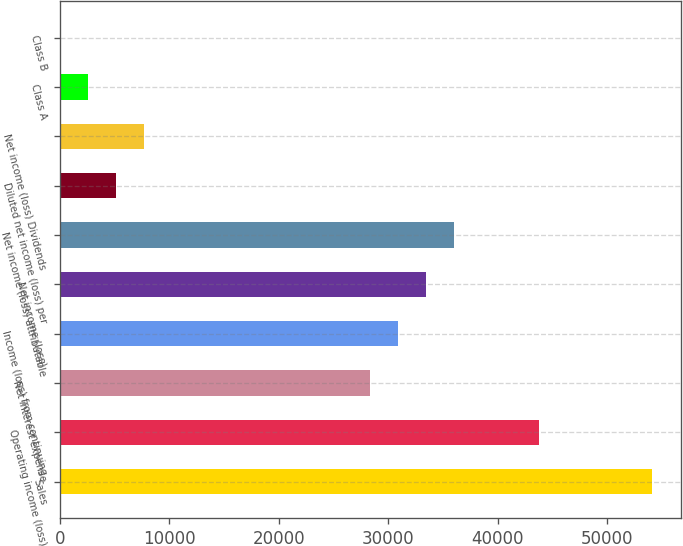Convert chart to OTSL. <chart><loc_0><loc_0><loc_500><loc_500><bar_chart><fcel>Sales<fcel>Operating income (loss)<fcel>Net interest expense<fcel>Income (loss) from continuing<fcel>Net income (loss)<fcel>Net income (loss) attributable<fcel>Diluted net income (loss) per<fcel>Net income (loss) Dividends<fcel>Class A<fcel>Class B<nl><fcel>54030.8<fcel>43739.3<fcel>28301.9<fcel>30874.8<fcel>33447.7<fcel>36020.6<fcel>5145.92<fcel>7718.81<fcel>2573.03<fcel>0.14<nl></chart> 